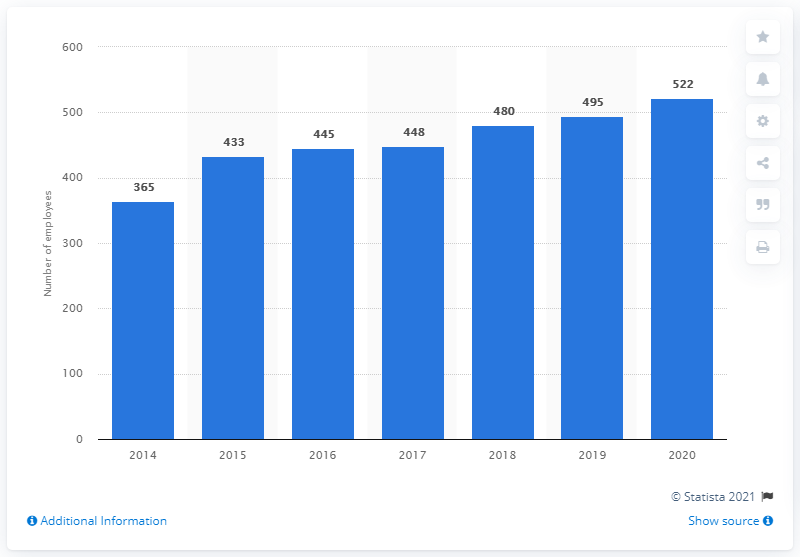List a handful of essential elements in this visual. In 2020, WD-40 Company employed 522 employees. 